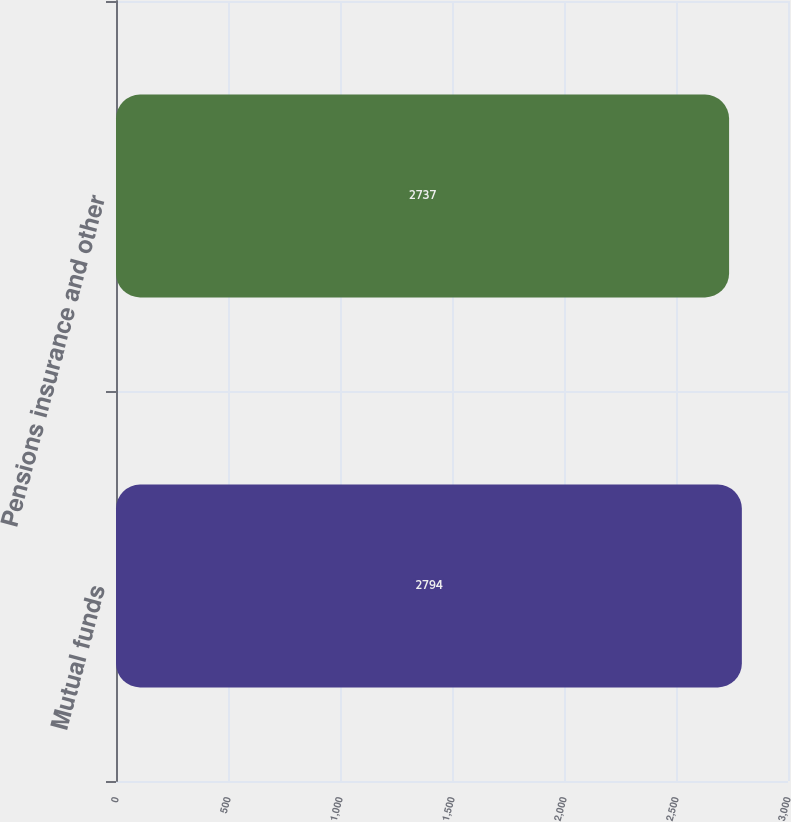Convert chart to OTSL. <chart><loc_0><loc_0><loc_500><loc_500><bar_chart><fcel>Mutual funds<fcel>Pensions insurance and other<nl><fcel>2794<fcel>2737<nl></chart> 